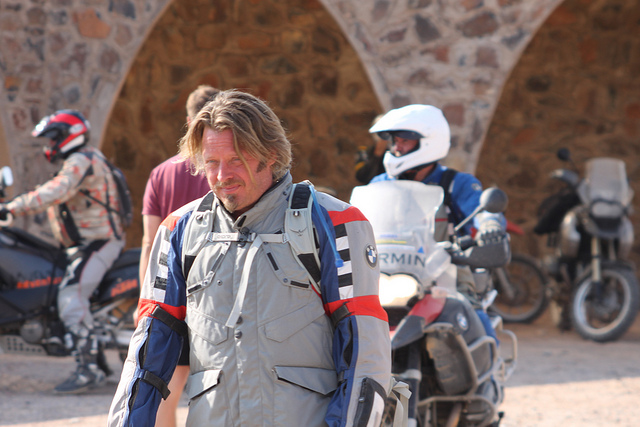Please extract the text content from this image. RMIN 